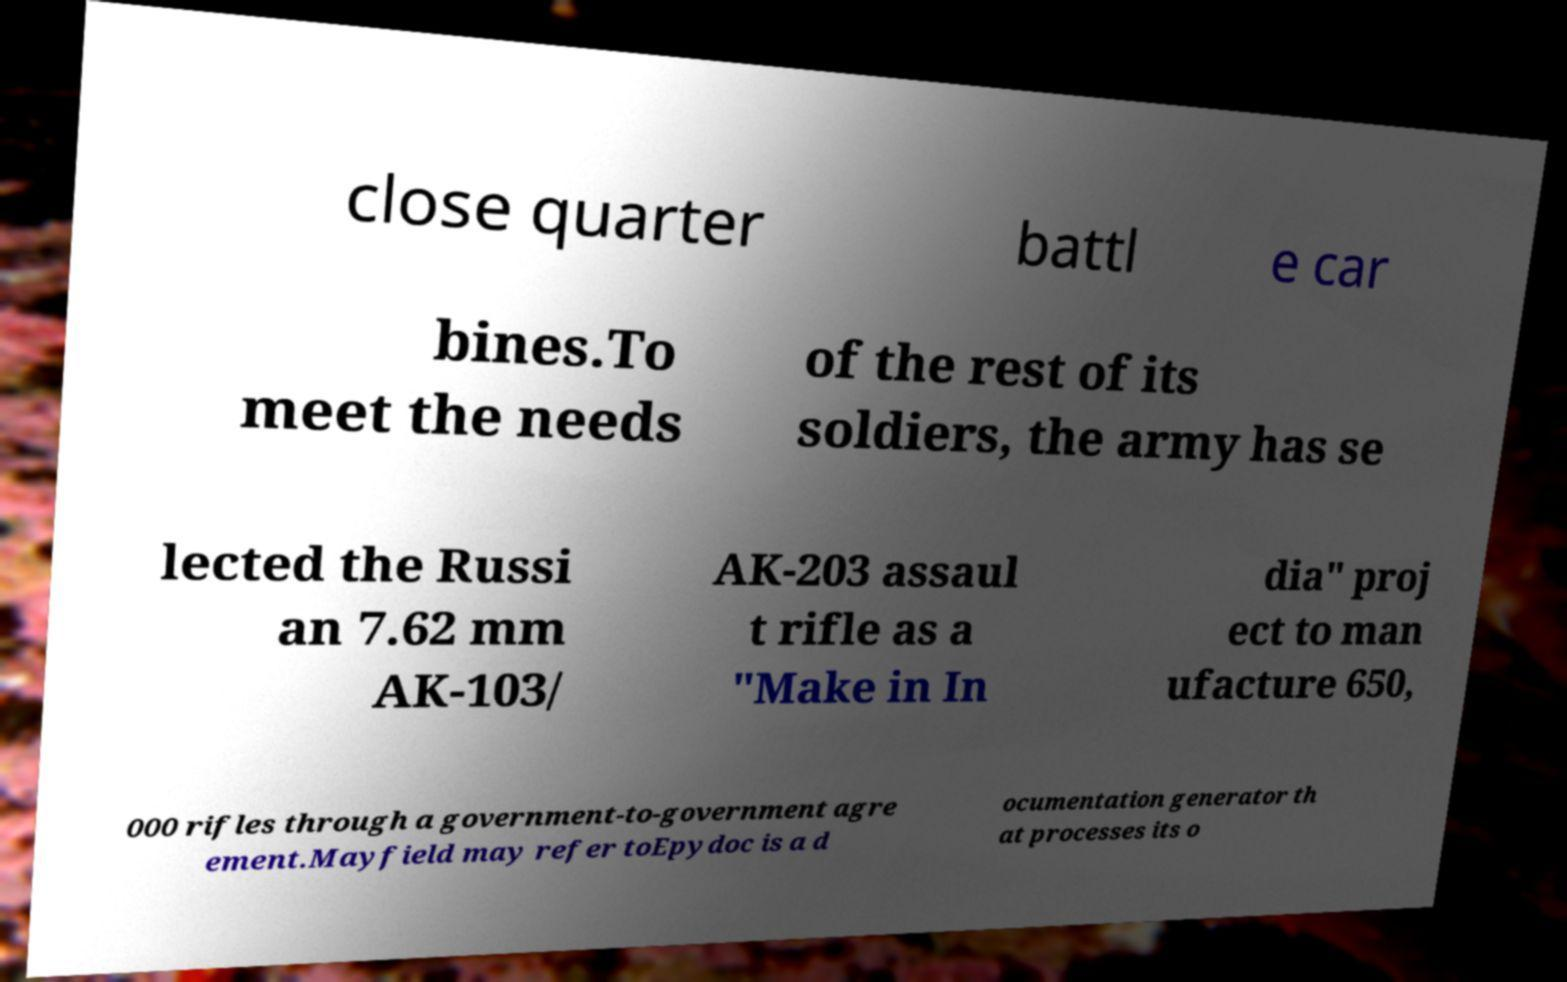Can you accurately transcribe the text from the provided image for me? close quarter battl e car bines.To meet the needs of the rest of its soldiers, the army has se lected the Russi an 7.62 mm AK-103/ AK-203 assaul t rifle as a "Make in In dia" proj ect to man ufacture 650, 000 rifles through a government-to-government agre ement.Mayfield may refer toEpydoc is a d ocumentation generator th at processes its o 